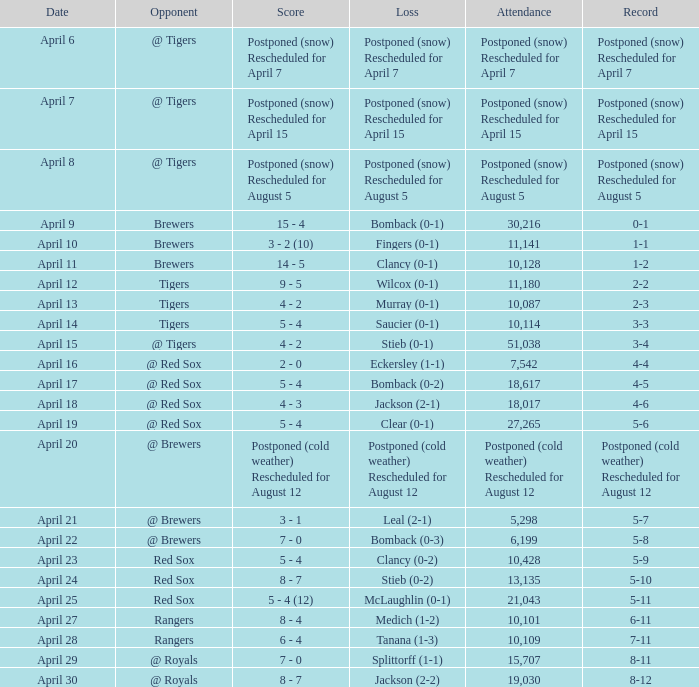What is the score for the game that has an attendance of 5,298? 3 - 1. 